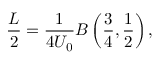Convert formula to latex. <formula><loc_0><loc_0><loc_500><loc_500>\frac { L } { 2 } = \frac { 1 } { 4 U _ { 0 } } B \left ( \frac { 3 } { 4 } , \frac { 1 } { 2 } \right ) ,</formula> 